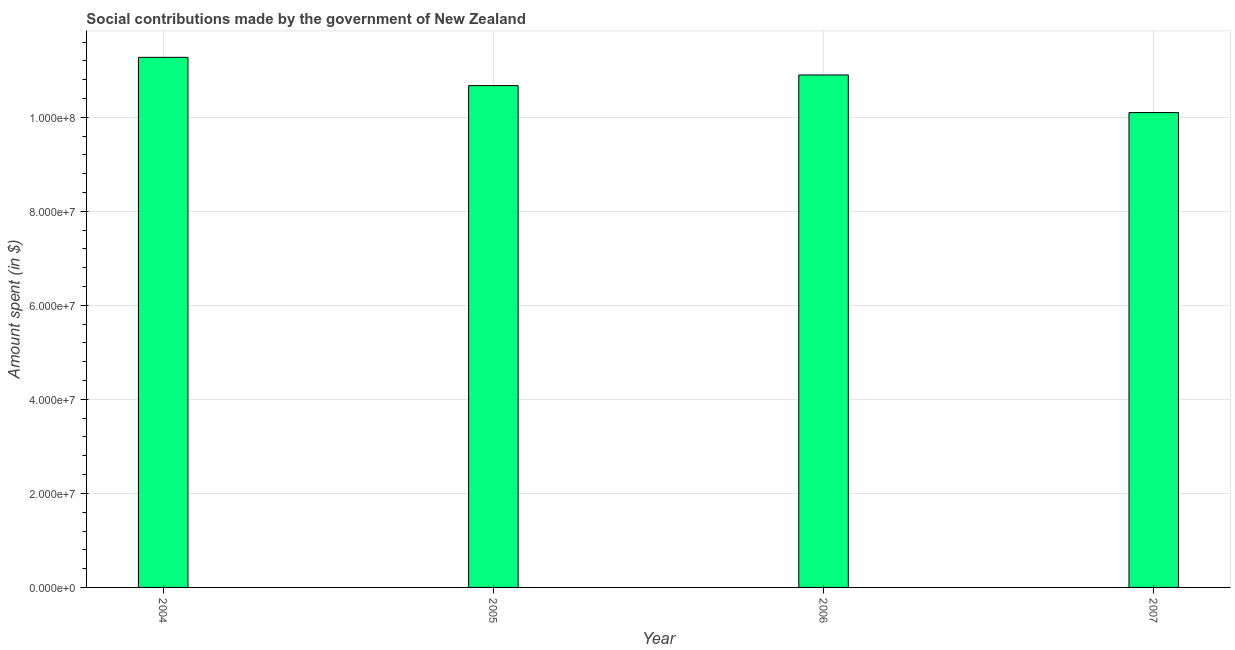What is the title of the graph?
Keep it short and to the point. Social contributions made by the government of New Zealand. What is the label or title of the X-axis?
Provide a short and direct response. Year. What is the label or title of the Y-axis?
Keep it short and to the point. Amount spent (in $). What is the amount spent in making social contributions in 2004?
Offer a very short reply. 1.13e+08. Across all years, what is the maximum amount spent in making social contributions?
Your answer should be very brief. 1.13e+08. Across all years, what is the minimum amount spent in making social contributions?
Offer a terse response. 1.01e+08. In which year was the amount spent in making social contributions maximum?
Give a very brief answer. 2004. What is the sum of the amount spent in making social contributions?
Your answer should be compact. 4.29e+08. What is the difference between the amount spent in making social contributions in 2005 and 2007?
Your answer should be very brief. 5.74e+06. What is the average amount spent in making social contributions per year?
Offer a terse response. 1.07e+08. What is the median amount spent in making social contributions?
Offer a very short reply. 1.08e+08. Do a majority of the years between 2006 and 2007 (inclusive) have amount spent in making social contributions greater than 108000000 $?
Provide a short and direct response. No. What is the ratio of the amount spent in making social contributions in 2004 to that in 2005?
Provide a succinct answer. 1.06. Is the difference between the amount spent in making social contributions in 2004 and 2005 greater than the difference between any two years?
Provide a succinct answer. No. What is the difference between the highest and the second highest amount spent in making social contributions?
Your answer should be compact. 3.75e+06. Is the sum of the amount spent in making social contributions in 2005 and 2007 greater than the maximum amount spent in making social contributions across all years?
Give a very brief answer. Yes. What is the difference between the highest and the lowest amount spent in making social contributions?
Offer a very short reply. 1.18e+07. How many bars are there?
Offer a terse response. 4. How many years are there in the graph?
Your answer should be very brief. 4. What is the Amount spent (in $) of 2004?
Your answer should be very brief. 1.13e+08. What is the Amount spent (in $) in 2005?
Your response must be concise. 1.07e+08. What is the Amount spent (in $) in 2006?
Your answer should be very brief. 1.09e+08. What is the Amount spent (in $) of 2007?
Give a very brief answer. 1.01e+08. What is the difference between the Amount spent (in $) in 2004 and 2005?
Your answer should be very brief. 6.02e+06. What is the difference between the Amount spent (in $) in 2004 and 2006?
Your response must be concise. 3.75e+06. What is the difference between the Amount spent (in $) in 2004 and 2007?
Your answer should be very brief. 1.18e+07. What is the difference between the Amount spent (in $) in 2005 and 2006?
Make the answer very short. -2.26e+06. What is the difference between the Amount spent (in $) in 2005 and 2007?
Your response must be concise. 5.74e+06. What is the ratio of the Amount spent (in $) in 2004 to that in 2005?
Offer a very short reply. 1.06. What is the ratio of the Amount spent (in $) in 2004 to that in 2006?
Provide a succinct answer. 1.03. What is the ratio of the Amount spent (in $) in 2004 to that in 2007?
Provide a short and direct response. 1.12. What is the ratio of the Amount spent (in $) in 2005 to that in 2006?
Ensure brevity in your answer.  0.98. What is the ratio of the Amount spent (in $) in 2005 to that in 2007?
Offer a very short reply. 1.06. What is the ratio of the Amount spent (in $) in 2006 to that in 2007?
Your response must be concise. 1.08. 